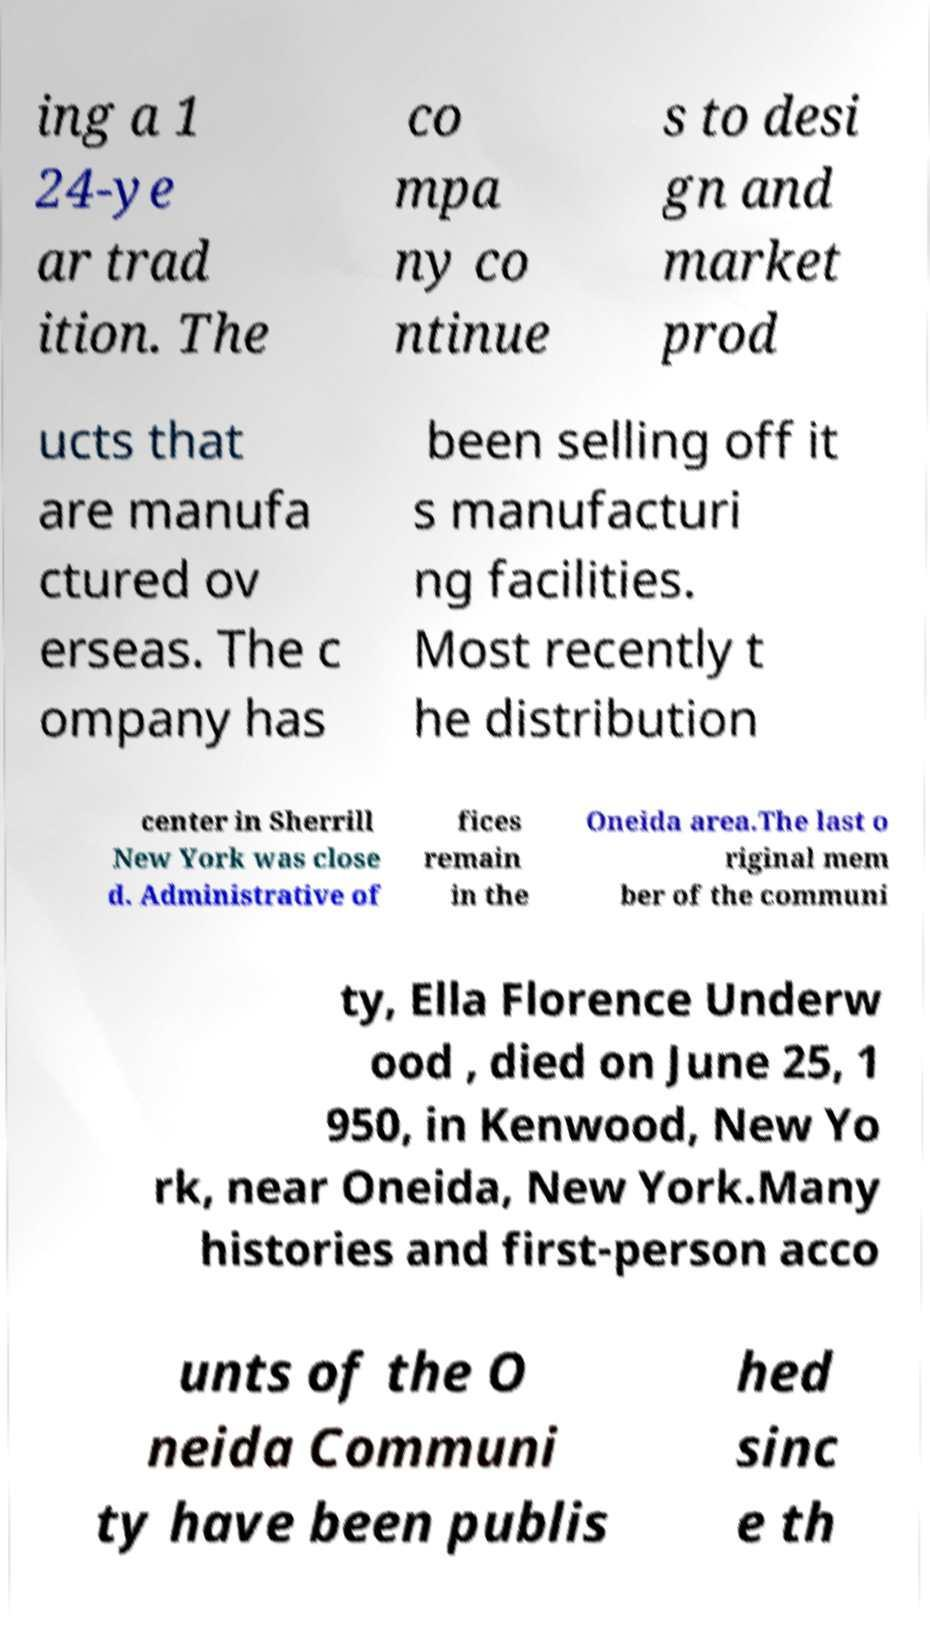Can you accurately transcribe the text from the provided image for me? ing a 1 24-ye ar trad ition. The co mpa ny co ntinue s to desi gn and market prod ucts that are manufa ctured ov erseas. The c ompany has been selling off it s manufacturi ng facilities. Most recently t he distribution center in Sherrill New York was close d. Administrative of fices remain in the Oneida area.The last o riginal mem ber of the communi ty, Ella Florence Underw ood , died on June 25, 1 950, in Kenwood, New Yo rk, near Oneida, New York.Many histories and first-person acco unts of the O neida Communi ty have been publis hed sinc e th 